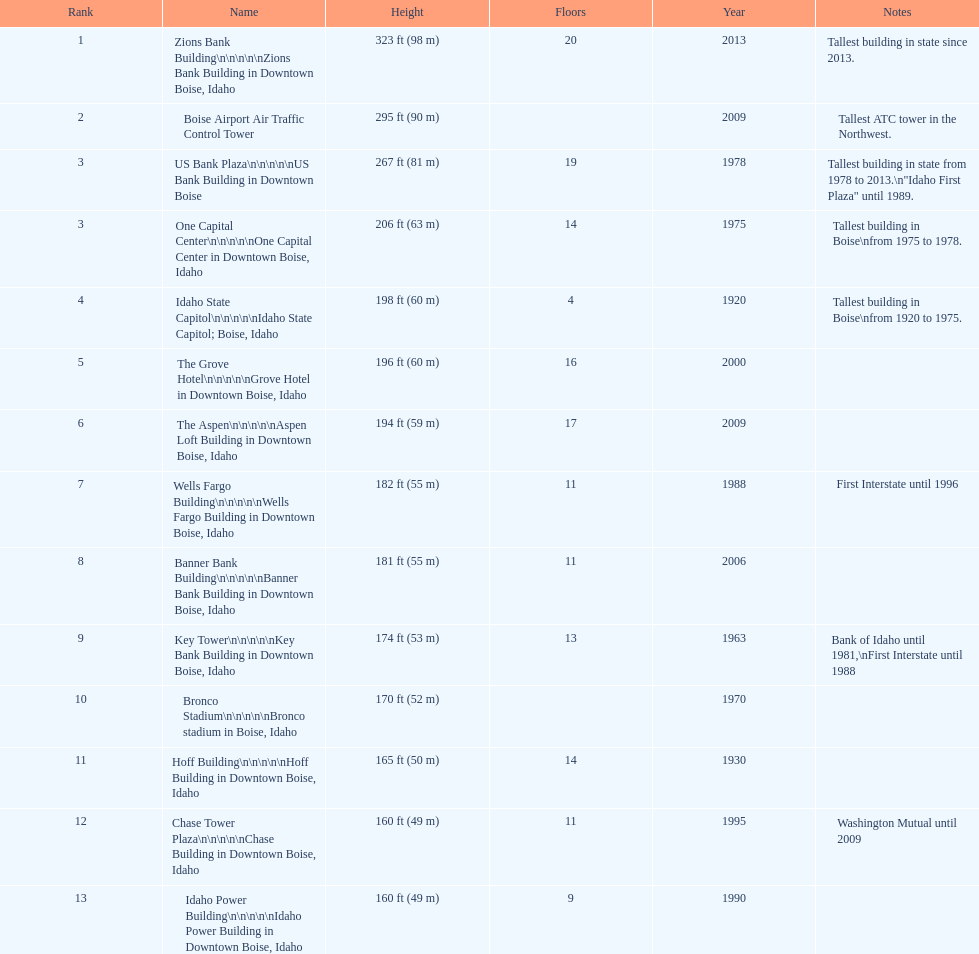What is the name of the last building on this chart? Idaho Power Building. 